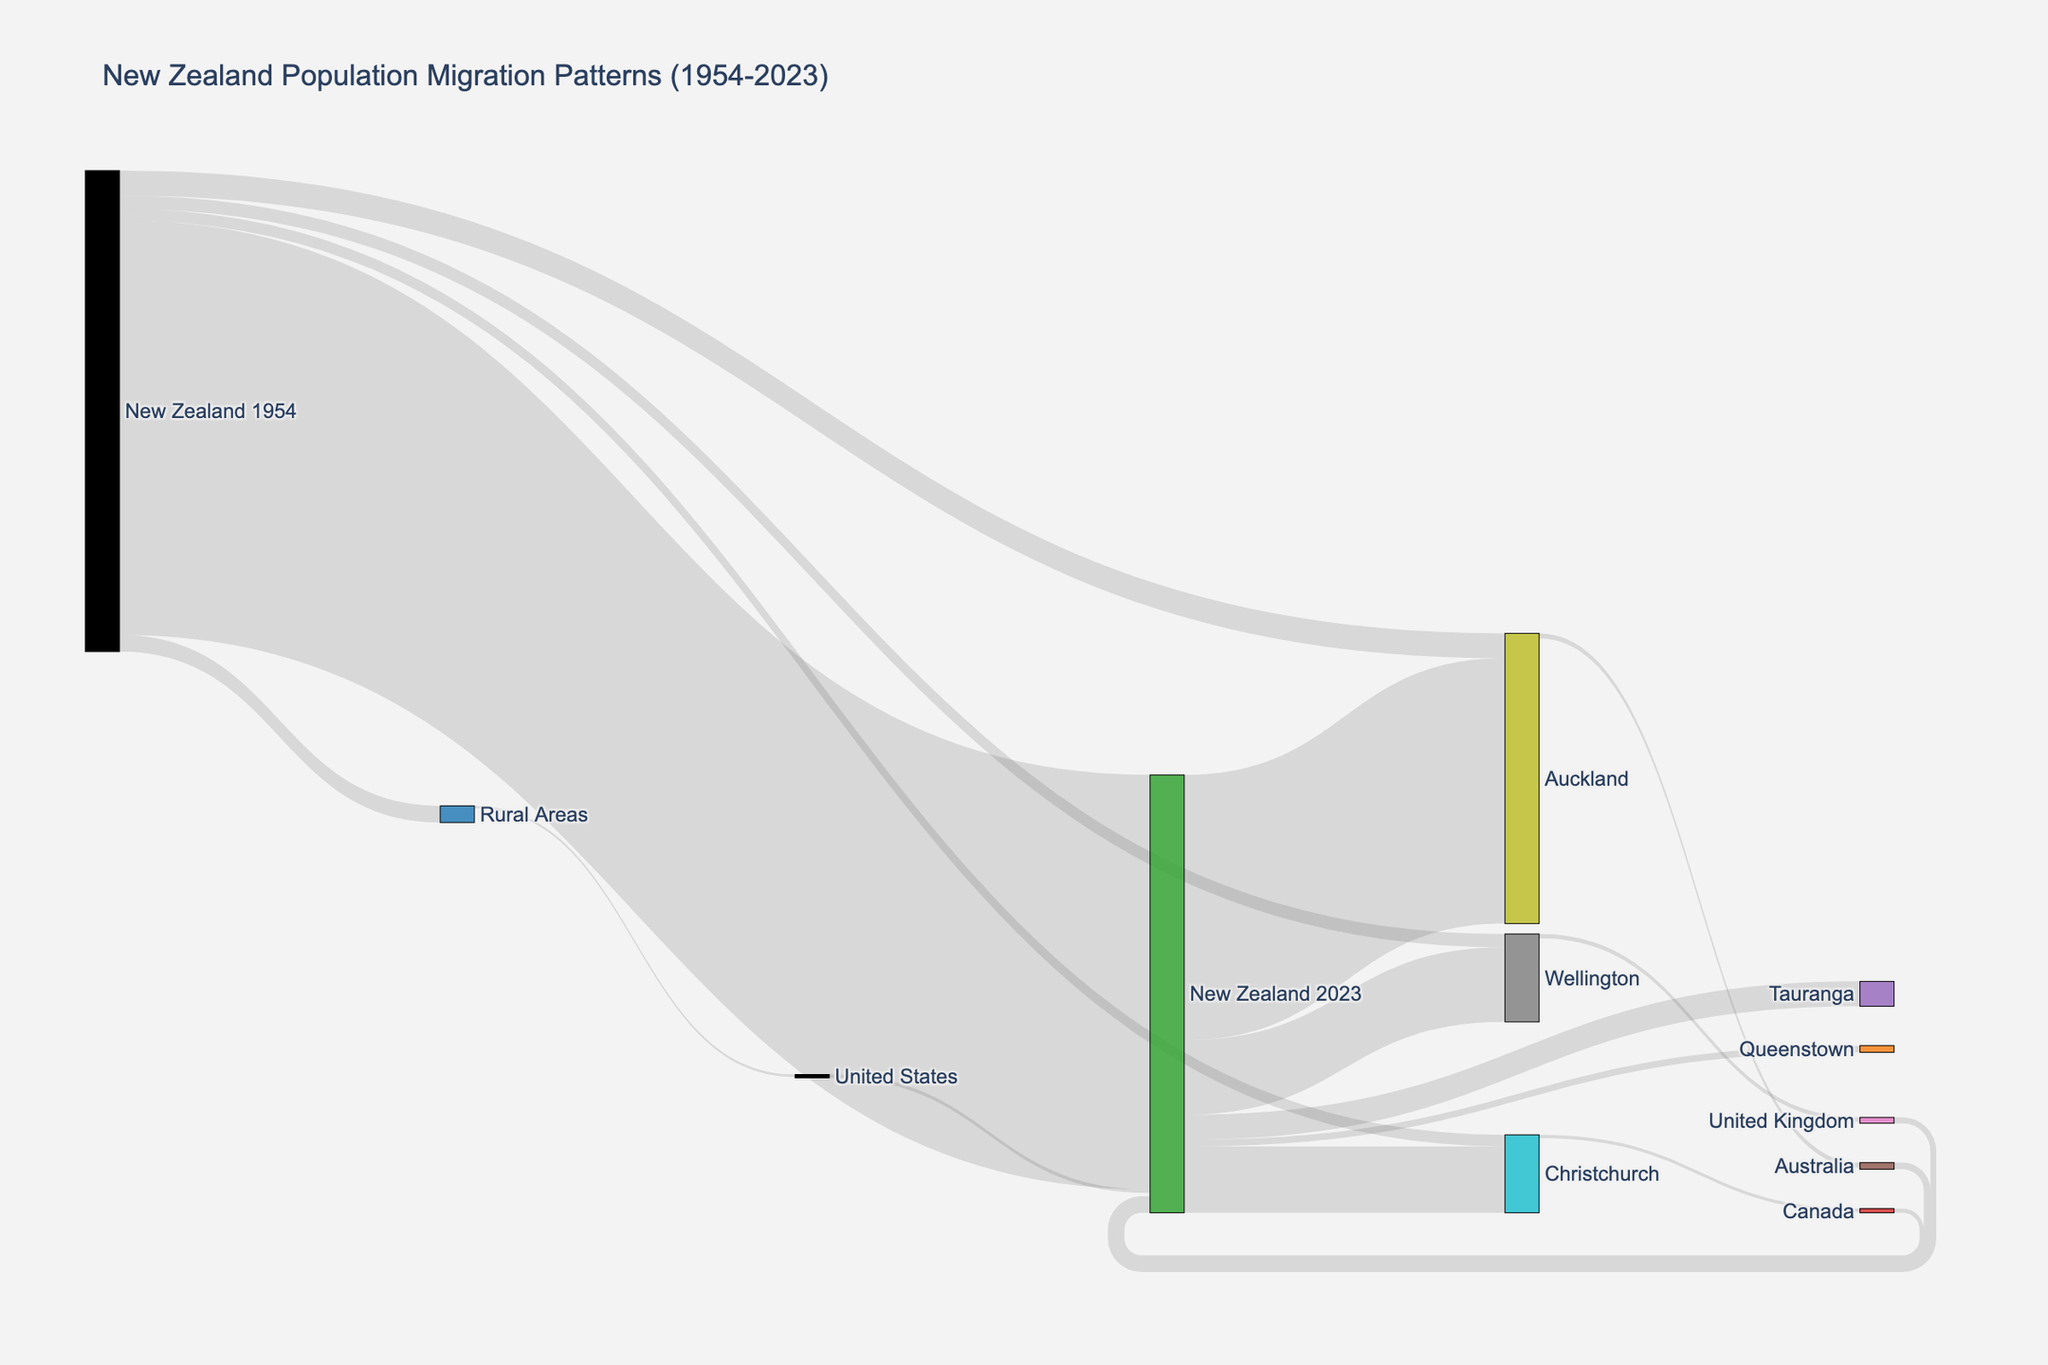What's the total population of New Zealand in 2023 according to the diagram? The Sankey diagram shows direct contributions from four sources: 2500000, 40000, 1600000, 450000, 400000, 40000, and 150000. Adding these up gives the total population.
Answer: 4,400,000 How many people migrated from Auckland to Australia? Locate the flow from Auckland to Australia in the diagram, which indicates the value of 30000.
Answer: 30,000 Which region had the highest migration rate from New Zealand in 1954? Observe the flows from "New Zealand 1954" to different targets (Auckland, Wellington, Christchurch, Rural Areas), comparing their values. Auckland has the highest migration value of 150000.
Answer: Auckland What color represents the node for Wellington? Identify the nodes by their labels to find Wellington, then look at the associated color, which is orange (or similar shade).
Answer: Orange Compare the number of people who migrated to the United States from Rural Areas and to Canada from Christchurch. Which is higher? Observe the flows to both countries: Rural Areas to the United States is 15000 and Christchurch to Canada is 20000. Canada has a higher value.
Answer: Canada What's the combined value of people who moved to Wellington and Christchurch from New Zealand 2023? Sum the values of flows to Wellington (450000) and Christchurch (400000).
Answer: 850,000 Did more people move from Australia to New Zealand 2023 or from the United Kingdom to New Zealand 2023? Compare the flows: Australia to New Zealand 2023 is 40000, and United Kingdom to New Zealand 2023 is 35000. More people moved from Australia.
Answer: Australia How many people remained in New Zealand from 1954 to 2023? Look for the flow from New Zealand 1954 to New Zealand 2023, which is marked by 2500000.
Answer: 2,500,000 What two nodes have the smallest inflow values in the Sankey diagram? Search for the targets with the smallest inflow values: Queenstown and the United States, both receiving 40000 each.
Answer: Queenstown and the United States Is the population migration flow from New Zealand 2023 to Tauranga greater or less than to Queenstown? Compare the two flows: 150000 go to Tauranga while 40000 go to Queenstown. Tauranga has a greater value.
Answer: Tauranga 